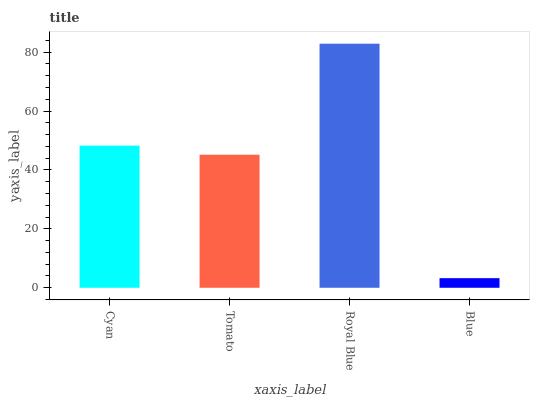Is Blue the minimum?
Answer yes or no. Yes. Is Royal Blue the maximum?
Answer yes or no. Yes. Is Tomato the minimum?
Answer yes or no. No. Is Tomato the maximum?
Answer yes or no. No. Is Cyan greater than Tomato?
Answer yes or no. Yes. Is Tomato less than Cyan?
Answer yes or no. Yes. Is Tomato greater than Cyan?
Answer yes or no. No. Is Cyan less than Tomato?
Answer yes or no. No. Is Cyan the high median?
Answer yes or no. Yes. Is Tomato the low median?
Answer yes or no. Yes. Is Tomato the high median?
Answer yes or no. No. Is Cyan the low median?
Answer yes or no. No. 